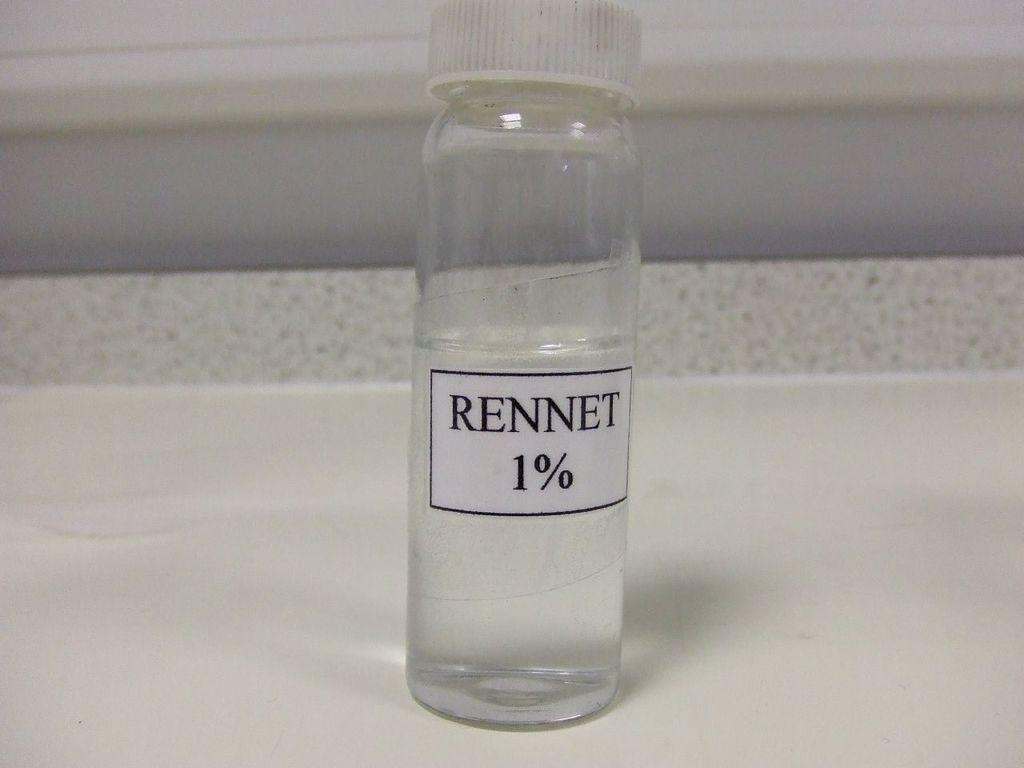<image>
Offer a succinct explanation of the picture presented. A clear bottle with 1% FRennet solution sits on a counter 